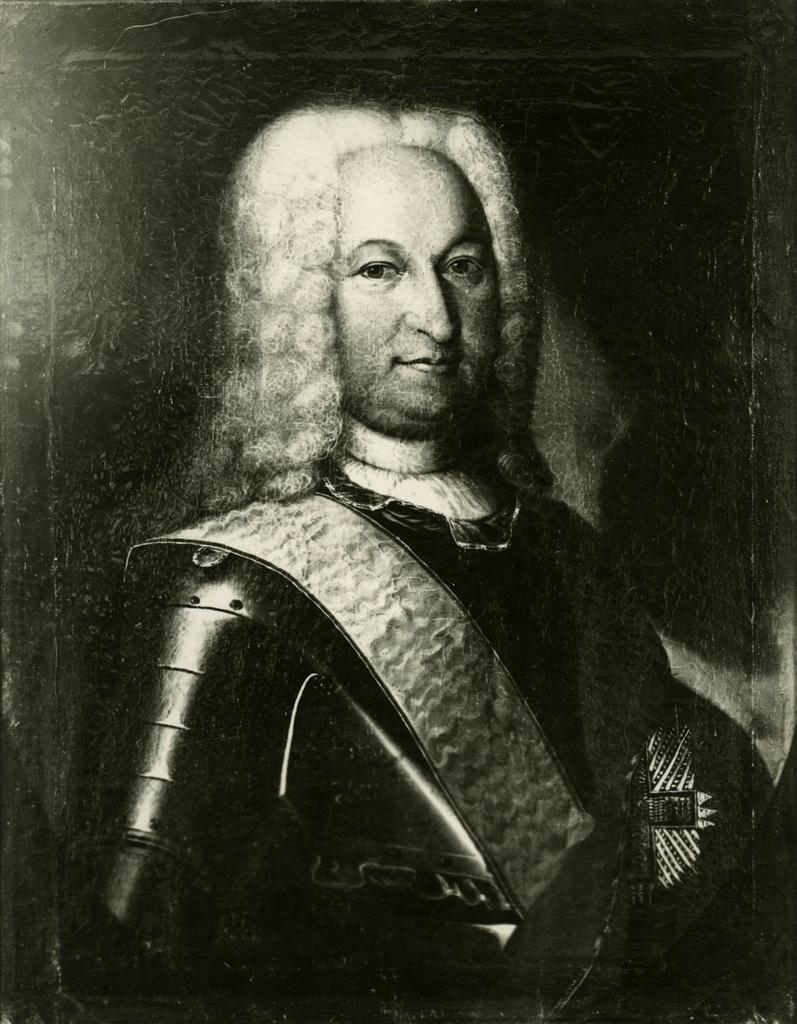Could you give a brief overview of what you see in this image? In the image we can see there is a person standing and he is wearing a jacket. The image is in black and white colour. 